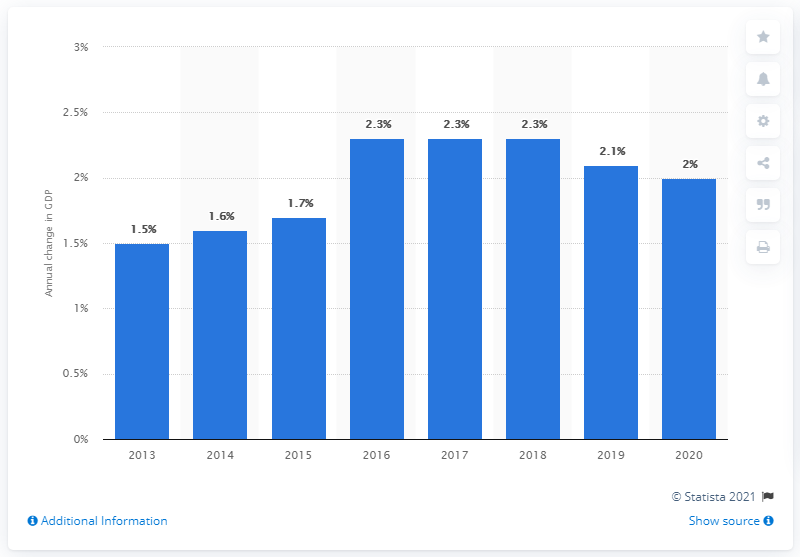Specify some key components in this picture. The projected increase in Montral's GDP in 2020 is expected to be [insert value]. 